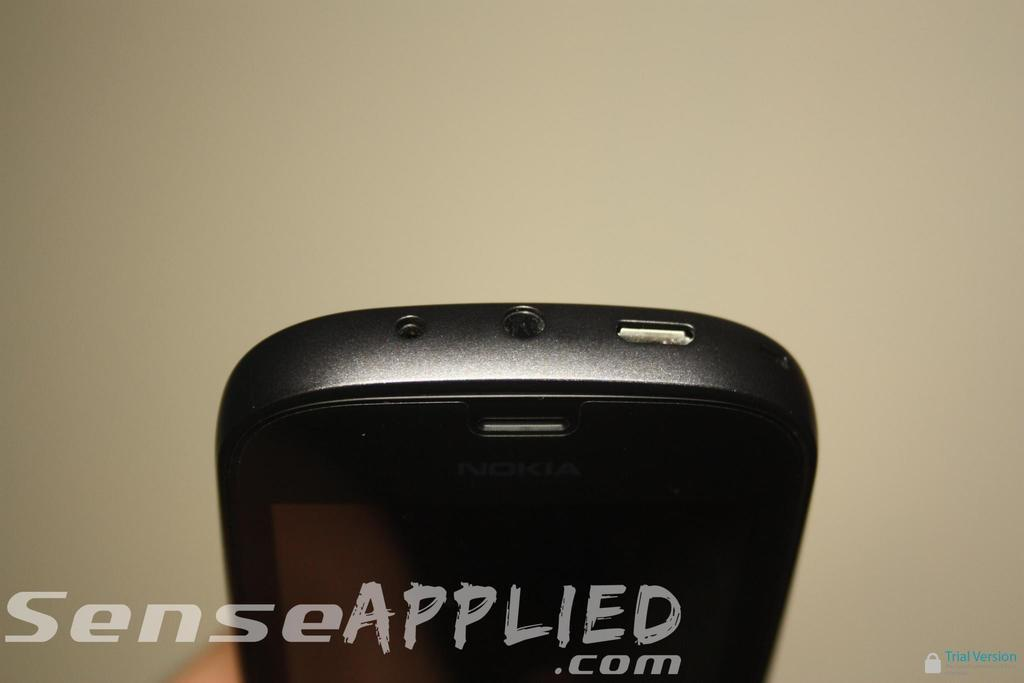<image>
Present a compact description of the photo's key features. The top of a smartphone showing the input jacks from senseapplied.com. 